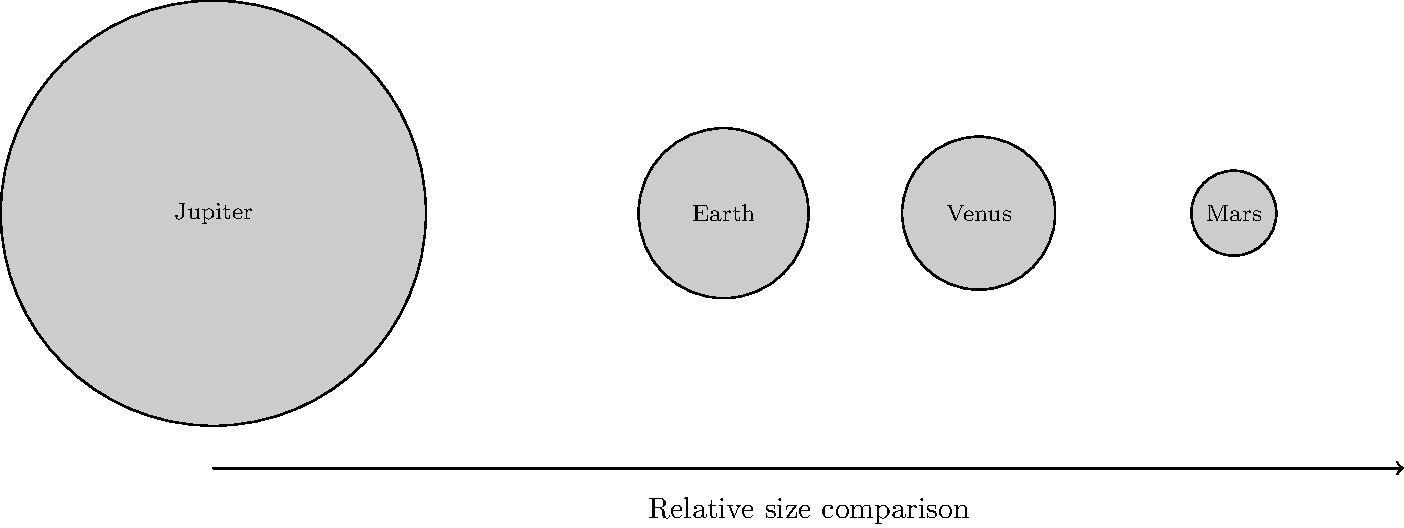As a community leader organizing an educational event on astronomy for local families, you want to include a question about planet sizes. Looking at the image, which planet is significantly larger than the others, and how might understanding planetary sizes contribute to our awareness of Earth's place in the solar system? 1. Observe the image: The diagram shows four planets from our solar system with their relative sizes.

2. Identify the largest planet: Jupiter is clearly much larger than the other planets shown.

3. Compare sizes:
   - Jupiter's diameter is about 2.5 times larger than Earth's in this image.
   - Earth and Venus appear similar in size, with Earth slightly larger.
   - Mars is the smallest planet shown, about half the size of Earth.

4. Understand Earth's place:
   - Earth is much smaller than Jupiter, the largest planet in our solar system.
   - Earth is comparable in size to Venus, often called Earth's "sister planet."
   - Earth is larger than Mars, but still relatively small in the context of the solar system.

5. Relevance to community awareness:
   - Understanding planetary sizes helps us grasp the vastness of space and our place in it.
   - This knowledge can inspire awe and curiosity about the universe, encouraging scientific thinking.
   - It can also foster a sense of unity and shared responsibility for our planet, as we see how unique and precious Earth is in the context of our solar system.

6. Crime prevention connection:
   - Educational activities like this can engage youth in positive, mind-expanding pursuits.
   - Fostering interest in science and astronomy can provide alternatives to negative behaviors and promote critical thinking skills useful in understanding and preventing crime.
Answer: Jupiter; it provides perspective on Earth's small size in the solar system, fostering appreciation for our planet and encouraging positive community engagement. 